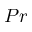Convert formula to latex. <formula><loc_0><loc_0><loc_500><loc_500>{ P r }</formula> 